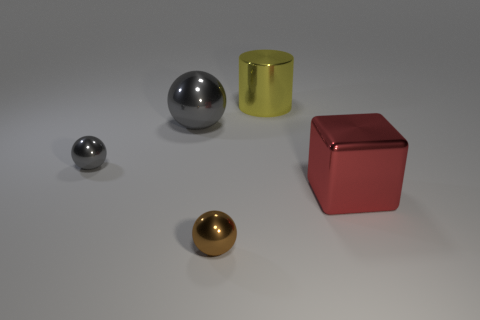The large thing that is in front of the metallic thing that is to the left of the big ball is what shape?
Provide a short and direct response. Cube. Do the big shiny cylinder and the thing to the right of the yellow shiny cylinder have the same color?
Provide a succinct answer. No. Is there a yellow shiny cylinder of the same size as the yellow metallic object?
Your response must be concise. No. Is the number of big red blocks greater than the number of tiny cubes?
Your response must be concise. Yes. What number of cylinders are tiny objects or gray things?
Ensure brevity in your answer.  0. The large cylinder has what color?
Keep it short and to the point. Yellow. There is a shiny ball that is in front of the red shiny block; does it have the same size as the object to the right of the large cylinder?
Keep it short and to the point. No. Is the number of big metallic spheres less than the number of large rubber things?
Offer a terse response. No. How many small shiny objects are behind the large red metal cube?
Provide a succinct answer. 1. What is the material of the red cube?
Your answer should be compact. Metal. 